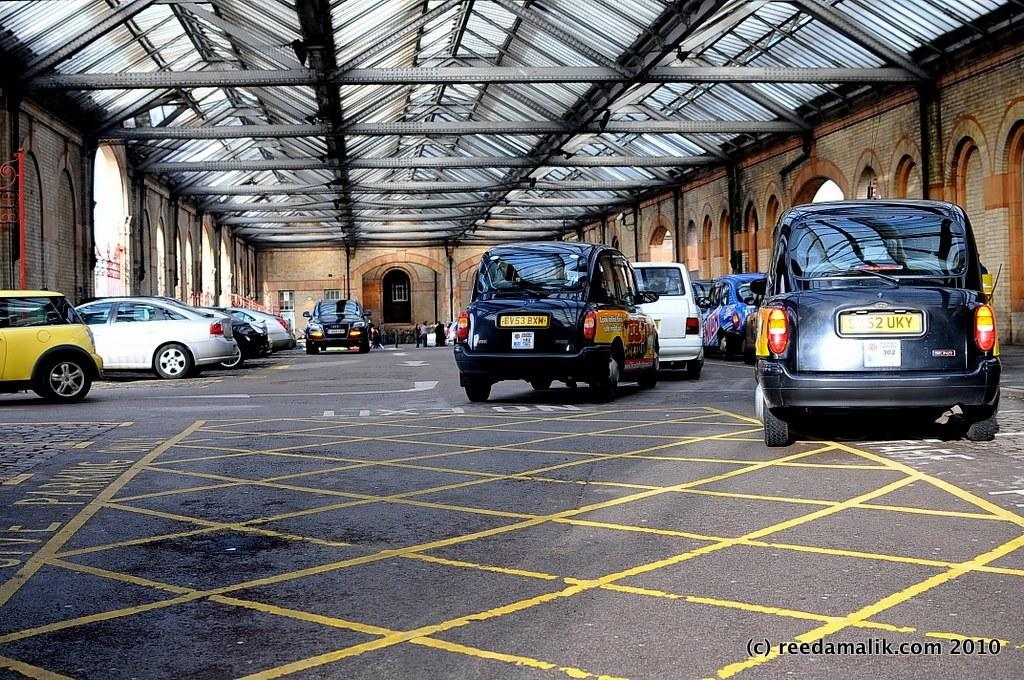<image>
Summarize the visual content of the image. A bunch of cars with the website reedamalik.com in the corner. 